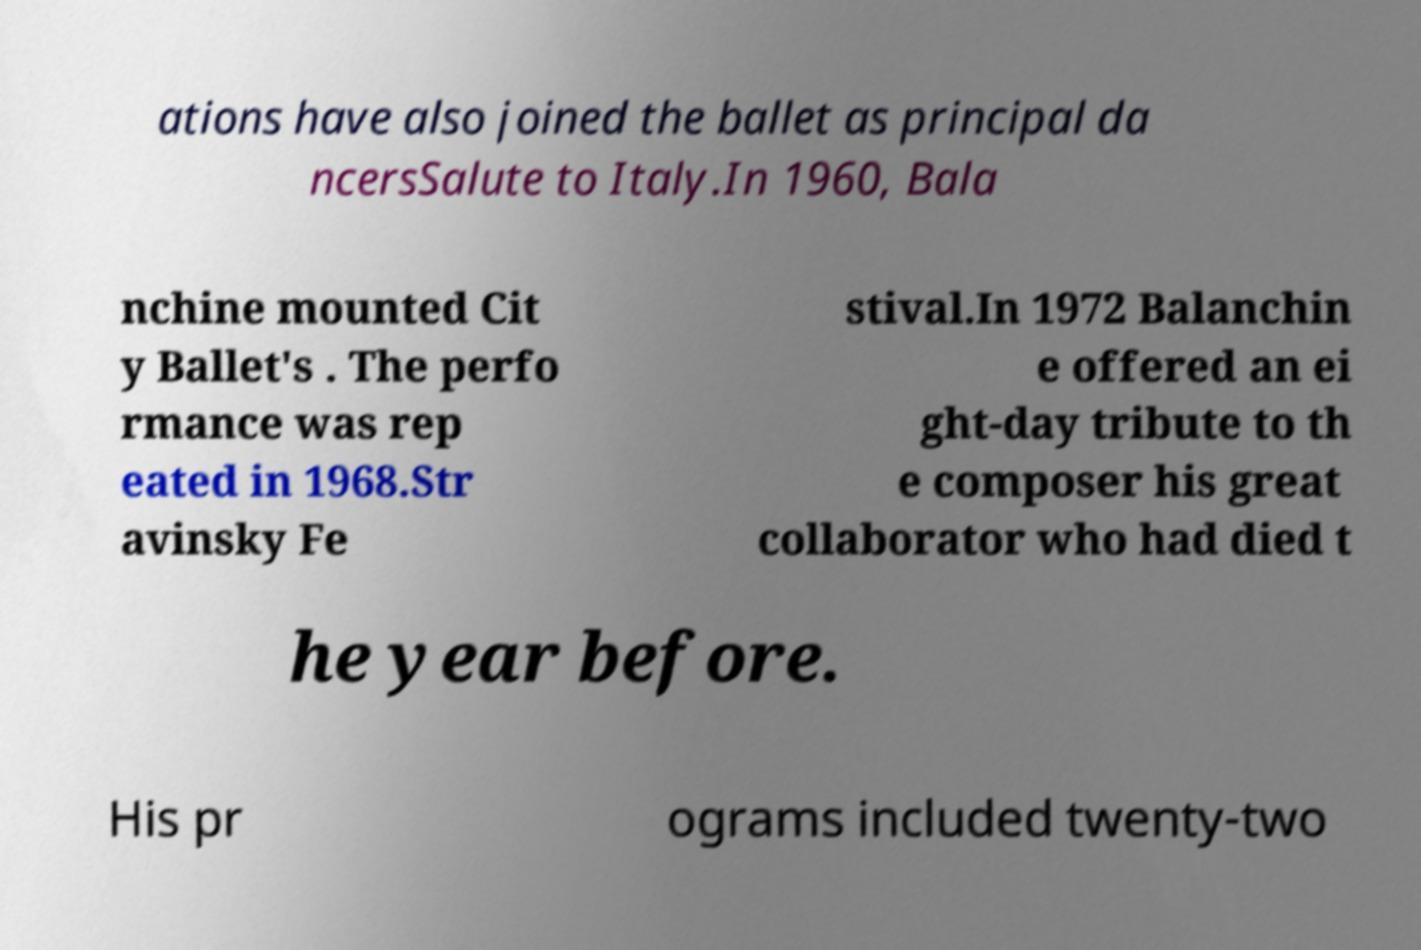Please read and relay the text visible in this image. What does it say? ations have also joined the ballet as principal da ncersSalute to Italy.In 1960, Bala nchine mounted Cit y Ballet's . The perfo rmance was rep eated in 1968.Str avinsky Fe stival.In 1972 Balanchin e offered an ei ght-day tribute to th e composer his great collaborator who had died t he year before. His pr ograms included twenty-two 